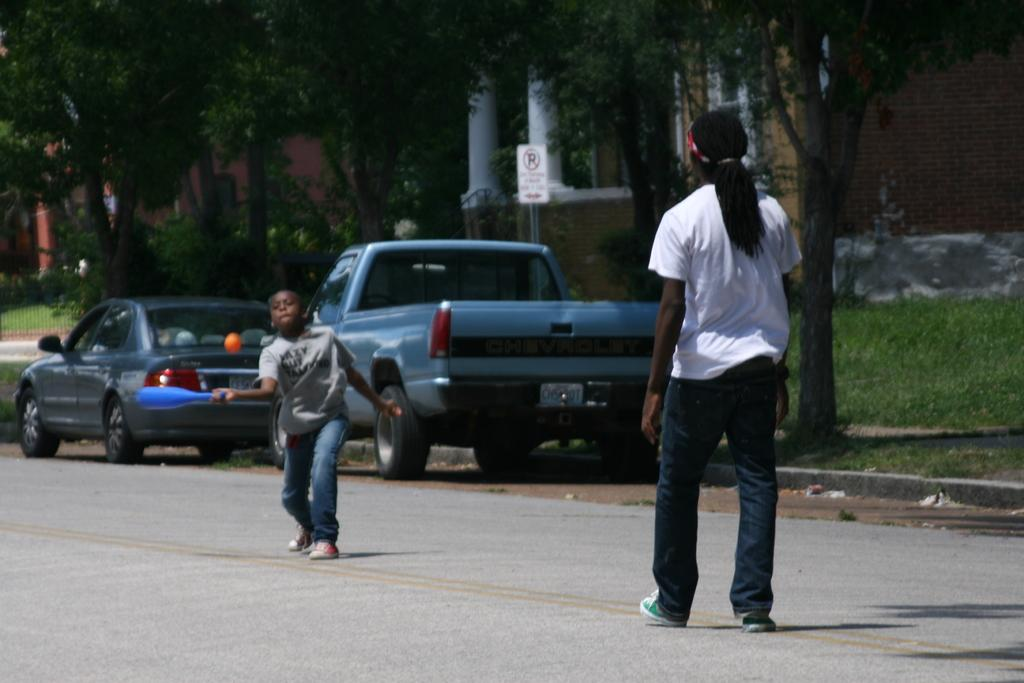Who is present in the image? There is a man and a boy in the image. What activity are they engaged in? The man and boy are playing baseball. Where are they playing baseball? They are playing on a road. What else can be seen in the image? There are vehicles visible in the image. What is visible in the background of the image? There are trees in the background of the image. Can you see an owl perched on the trees in the background of the image? There is no owl visible in the image; only the trees can be seen in the background. 